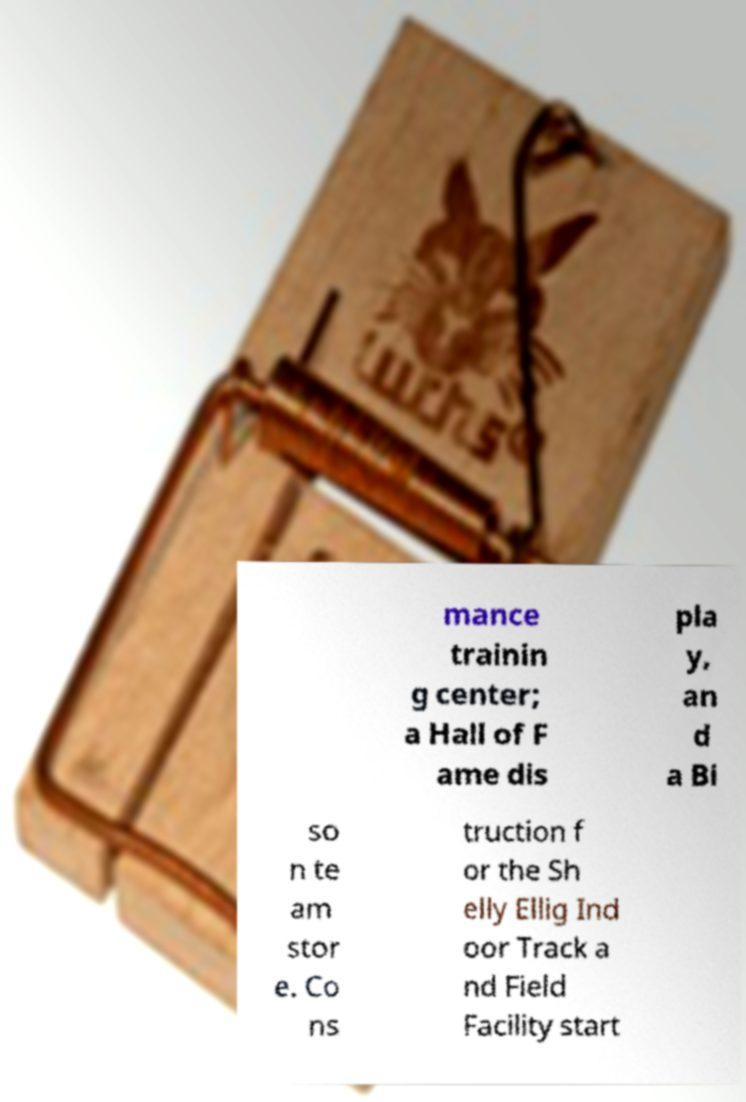What messages or text are displayed in this image? I need them in a readable, typed format. mance trainin g center; a Hall of F ame dis pla y, an d a Bi so n te am stor e. Co ns truction f or the Sh elly Ellig Ind oor Track a nd Field Facility start 